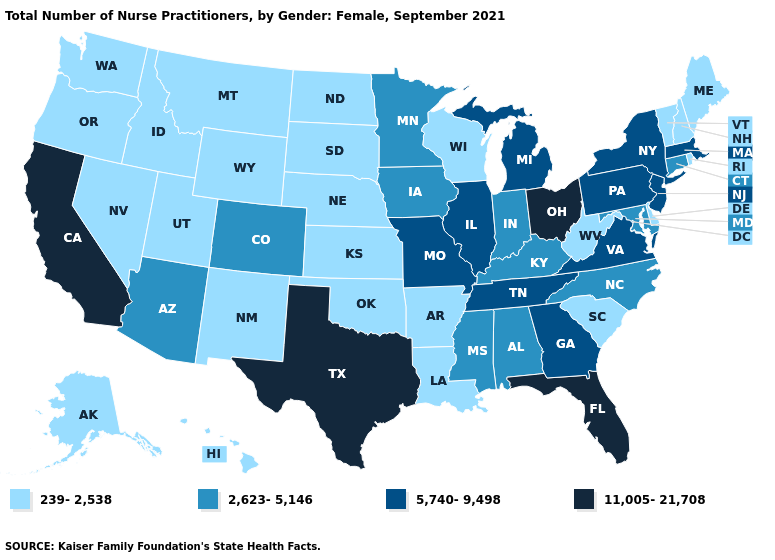What is the lowest value in the USA?
Give a very brief answer. 239-2,538. Does Rhode Island have the same value as Idaho?
Concise answer only. Yes. What is the lowest value in the USA?
Write a very short answer. 239-2,538. What is the value of New York?
Concise answer only. 5,740-9,498. Name the states that have a value in the range 5,740-9,498?
Short answer required. Georgia, Illinois, Massachusetts, Michigan, Missouri, New Jersey, New York, Pennsylvania, Tennessee, Virginia. Does Connecticut have the highest value in the Northeast?
Concise answer only. No. Which states have the lowest value in the Northeast?
Short answer required. Maine, New Hampshire, Rhode Island, Vermont. Is the legend a continuous bar?
Give a very brief answer. No. How many symbols are there in the legend?
Short answer required. 4. Name the states that have a value in the range 2,623-5,146?
Be succinct. Alabama, Arizona, Colorado, Connecticut, Indiana, Iowa, Kentucky, Maryland, Minnesota, Mississippi, North Carolina. What is the highest value in the USA?
Answer briefly. 11,005-21,708. Name the states that have a value in the range 2,623-5,146?
Short answer required. Alabama, Arizona, Colorado, Connecticut, Indiana, Iowa, Kentucky, Maryland, Minnesota, Mississippi, North Carolina. Which states have the highest value in the USA?
Quick response, please. California, Florida, Ohio, Texas. What is the value of New Jersey?
Be succinct. 5,740-9,498. Does Vermont have the lowest value in the Northeast?
Answer briefly. Yes. 